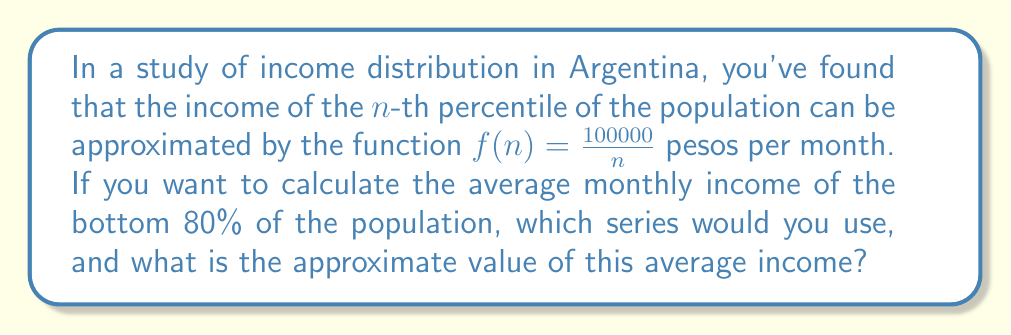Could you help me with this problem? To solve this problem, we need to follow these steps:

1) The income distribution follows a harmonic series pattern, where the income of the $n$-th percentile is given by $f(n) = \frac{100000}{n}$.

2) To find the average income of the bottom 80%, we need to sum up the incomes from the 1st to the 80th percentile and divide by 80.

3) This sum can be represented as:

   $$S = \frac{1}{80} \sum_{n=1}^{80} \frac{100000}{n}$$

4) This is a partial sum of the harmonic series multiplied by a constant. The general form of the partial sum of the harmonic series is:

   $$\sum_{n=1}^{N} \frac{1}{n} \approx \ln(N) + \gamma$$

   where $\gamma$ is the Euler-Mascheroni constant (approximately 0.5772).

5) Applying this to our sum:

   $$S = \frac{100000}{80} (\ln(80) + \gamma)$$

6) Calculating:
   $\ln(80) \approx 4.3820$
   $\gamma \approx 0.5772$

7) Therefore:

   $$S \approx \frac{100000}{80} (4.3820 + 0.5772) = \frac{100000}{80} (4.9592) = 6199$$

Thus, the average monthly income of the bottom 80% of the population is approximately 6199 pesos.
Answer: 6199 pesos 